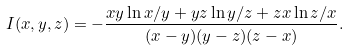<formula> <loc_0><loc_0><loc_500><loc_500>I ( x , y , z ) = - \frac { x y \ln x / y + y z \ln y / z + z x \ln z / x } { ( x - y ) ( y - z ) ( z - x ) } .</formula> 